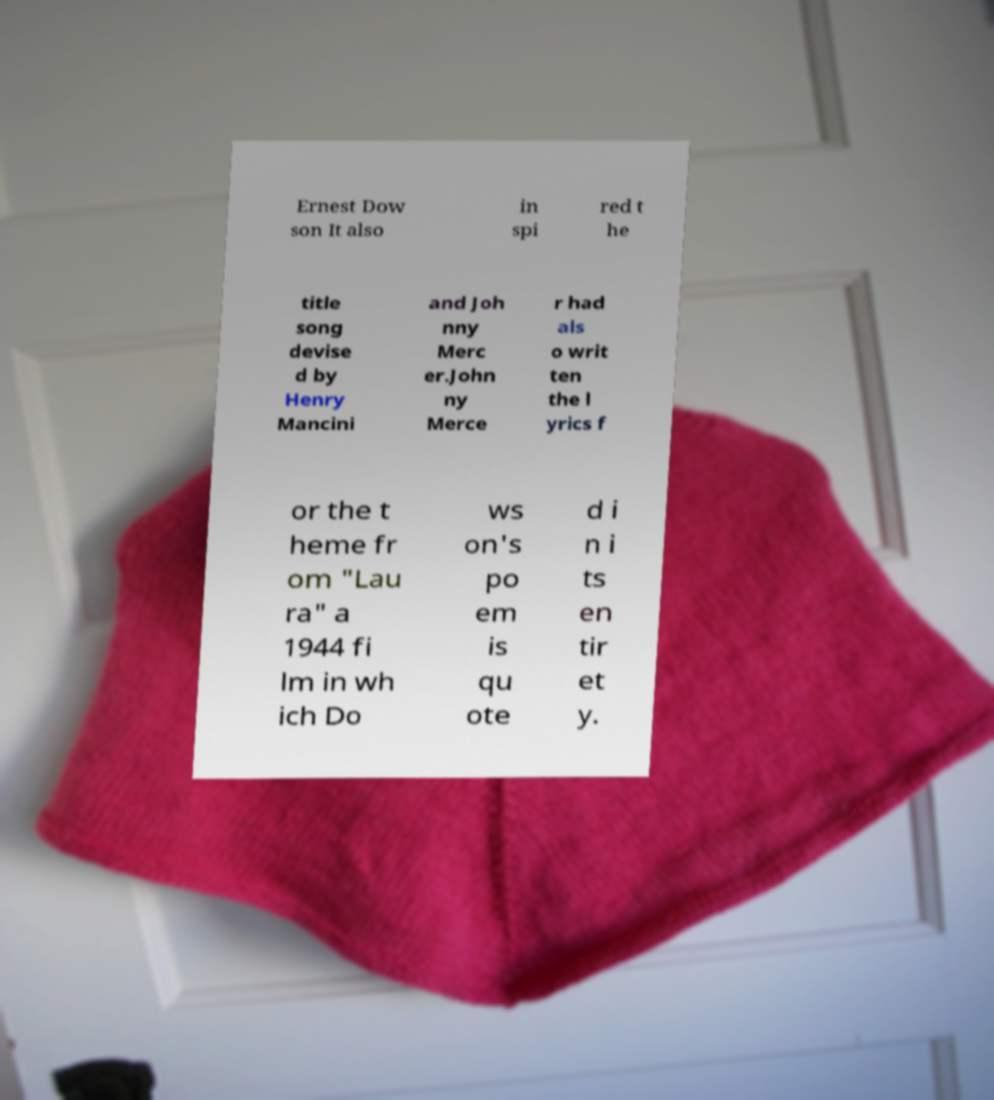Can you accurately transcribe the text from the provided image for me? Ernest Dow son It also in spi red t he title song devise d by Henry Mancini and Joh nny Merc er.John ny Merce r had als o writ ten the l yrics f or the t heme fr om "Lau ra" a 1944 fi lm in wh ich Do ws on's po em is qu ote d i n i ts en tir et y. 